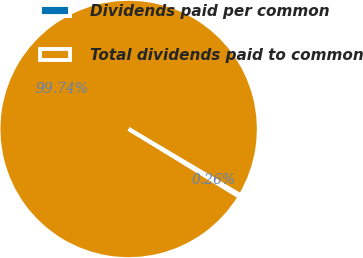Convert chart to OTSL. <chart><loc_0><loc_0><loc_500><loc_500><pie_chart><fcel>Dividends paid per common<fcel>Total dividends paid to common<nl><fcel>0.26%<fcel>99.74%<nl></chart> 